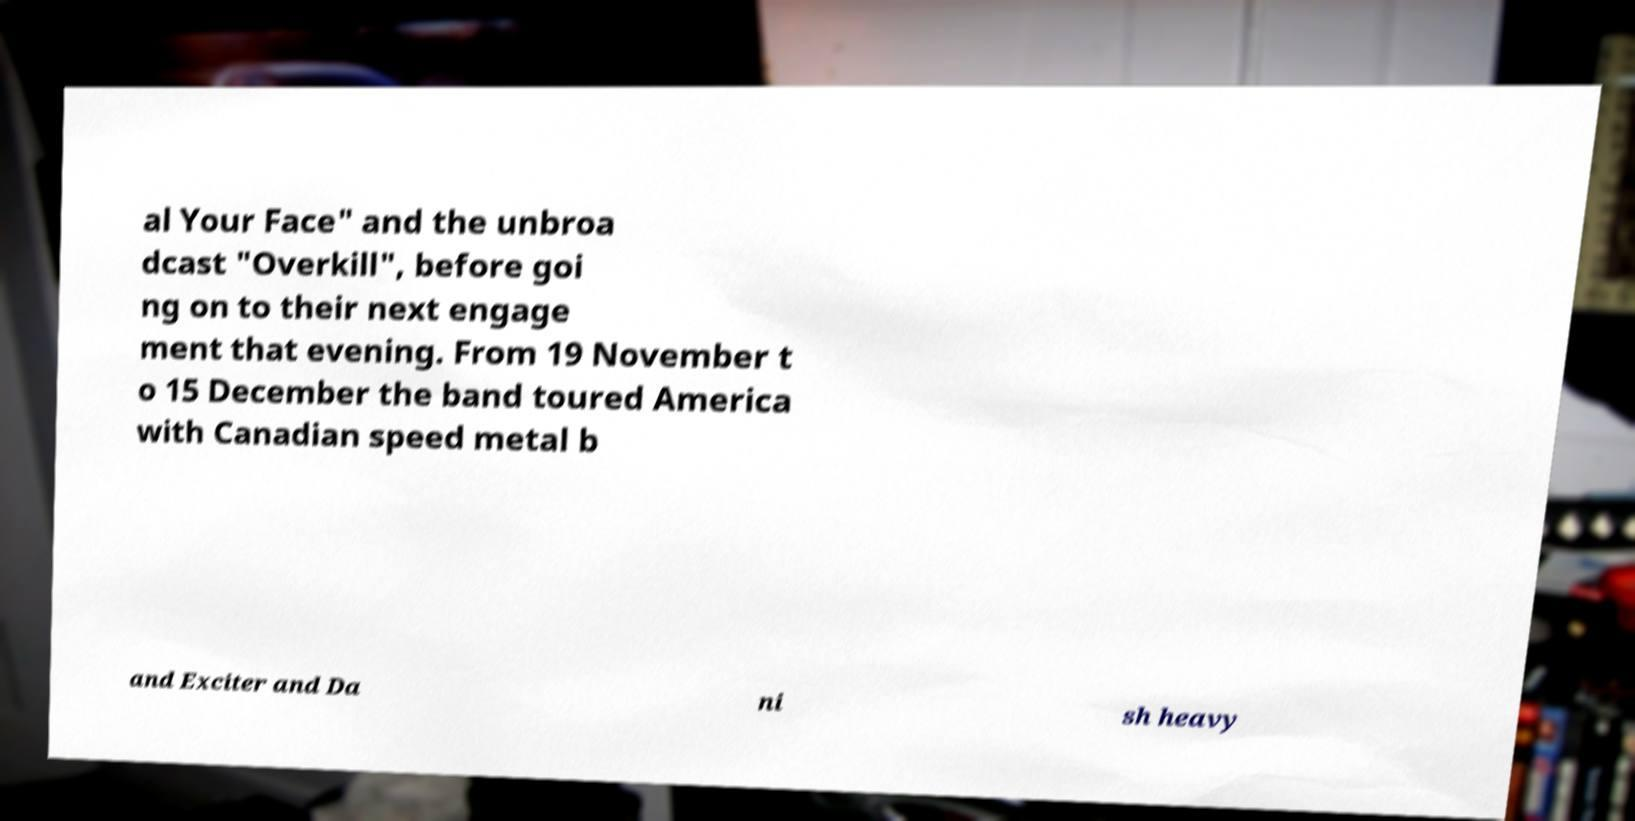Can you read and provide the text displayed in the image?This photo seems to have some interesting text. Can you extract and type it out for me? al Your Face" and the unbroa dcast "Overkill", before goi ng on to their next engage ment that evening. From 19 November t o 15 December the band toured America with Canadian speed metal b and Exciter and Da ni sh heavy 